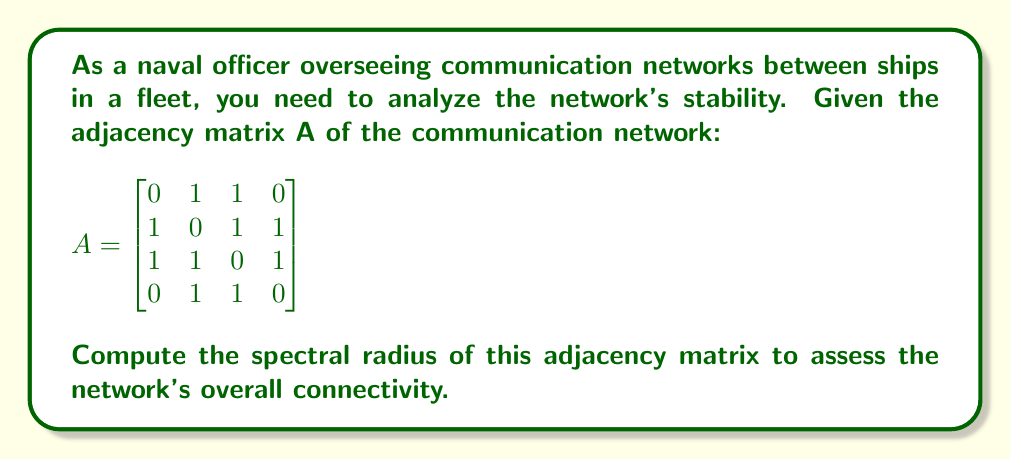What is the answer to this math problem? To compute the spectral radius of the adjacency matrix A, we need to follow these steps:

1. Find the characteristic polynomial of A:
   $det(A - \lambda I) = 0$

2. Expand the determinant:
   $$\begin{vmatrix}
   -\lambda & 1 & 1 & 0 \\
   1 & -\lambda & 1 & 1 \\
   1 & 1 & -\lambda & 1 \\
   0 & 1 & 1 & -\lambda
   \end{vmatrix} = 0$$

3. Solve the characteristic equation:
   $\lambda^4 - 6\lambda^2 - 4\lambda + 1 = 0$

4. Find the roots of this equation. The largest absolute value of these roots is the spectral radius.

5. Using numerical methods or a computer algebra system, we find the roots:
   $\lambda_1 \approx 2.5616$
   $\lambda_2 \approx -1.6861$
   $\lambda_3 \approx 0.5622 + 0.4252i$
   $\lambda_4 \approx 0.5622 - 0.4252i$

6. The spectral radius is the largest absolute value among these eigenvalues, which is $|\lambda_1| \approx 2.5616$.

This spectral radius indicates the overall connectivity and robustness of the communication network between the ships in the fleet.
Answer: $2.5616$ 